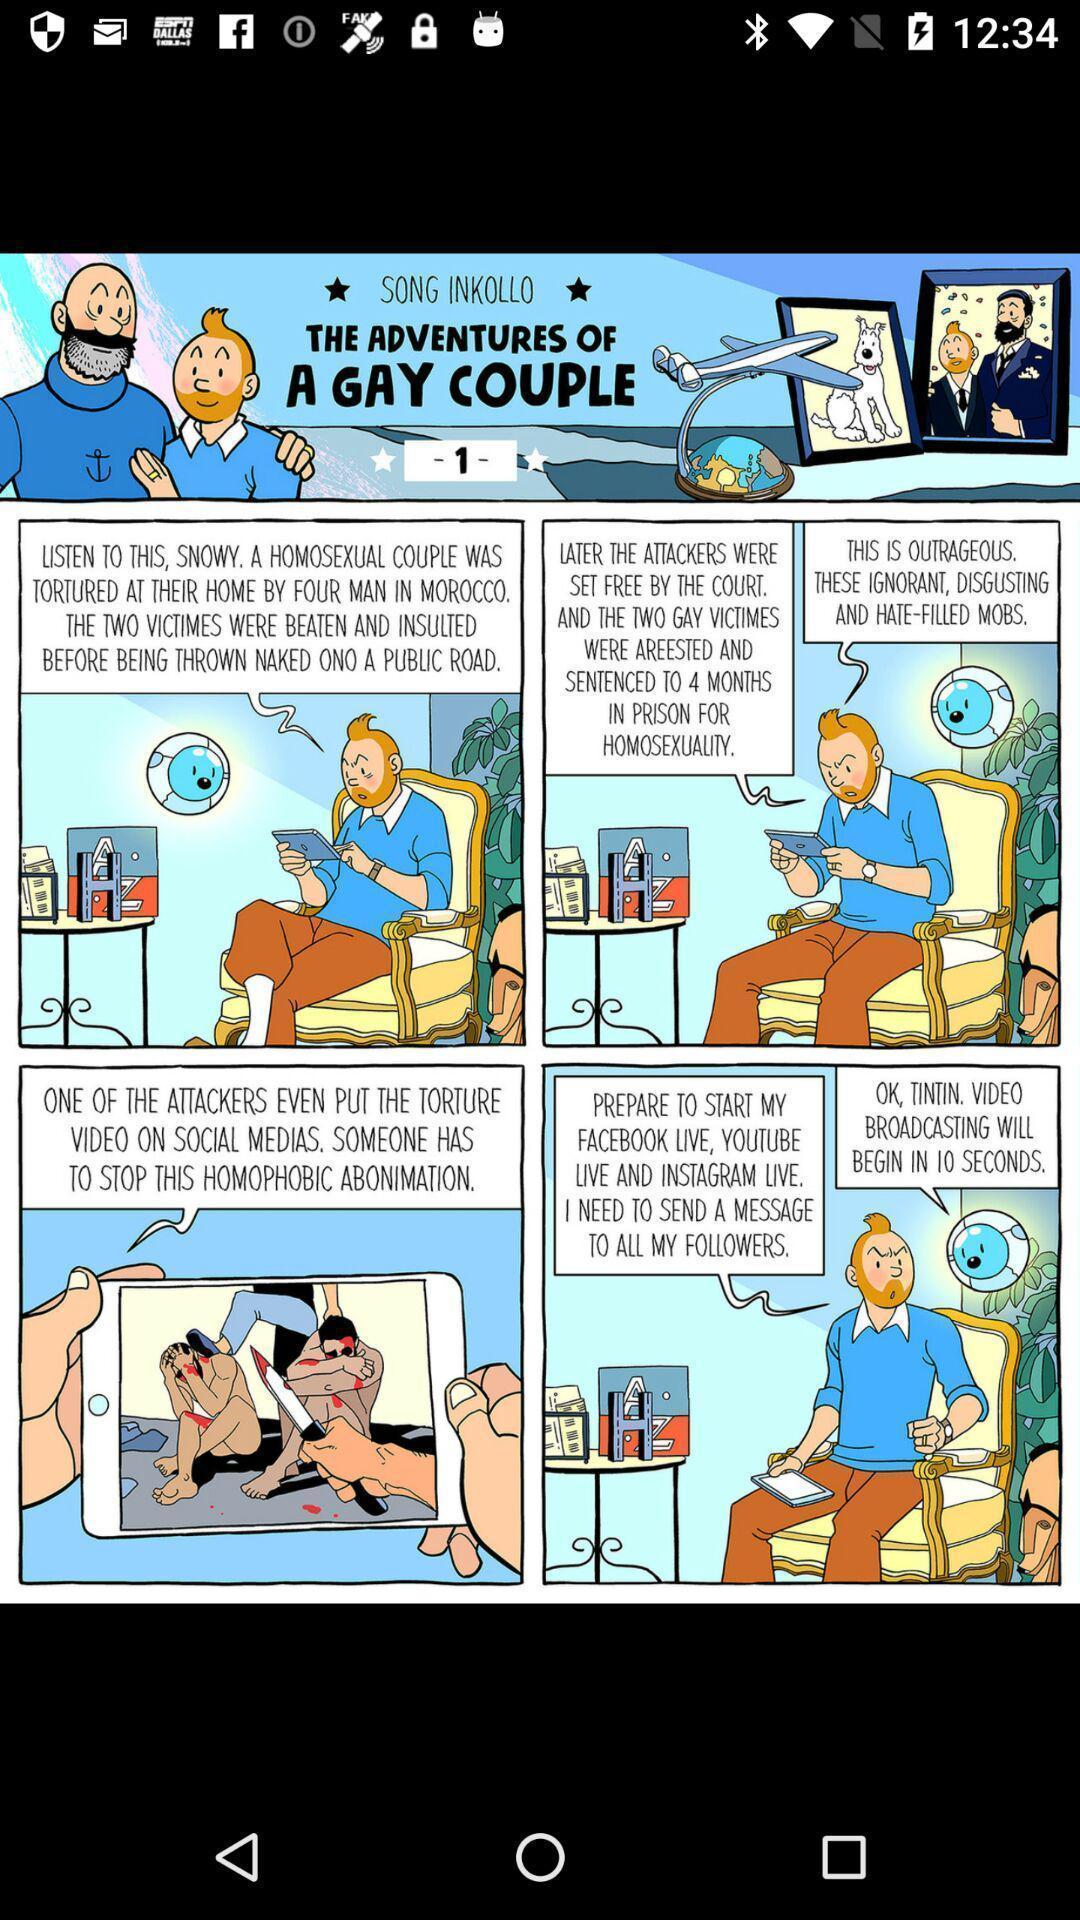Summarize the information in this screenshot. Page that displaying adventures. 